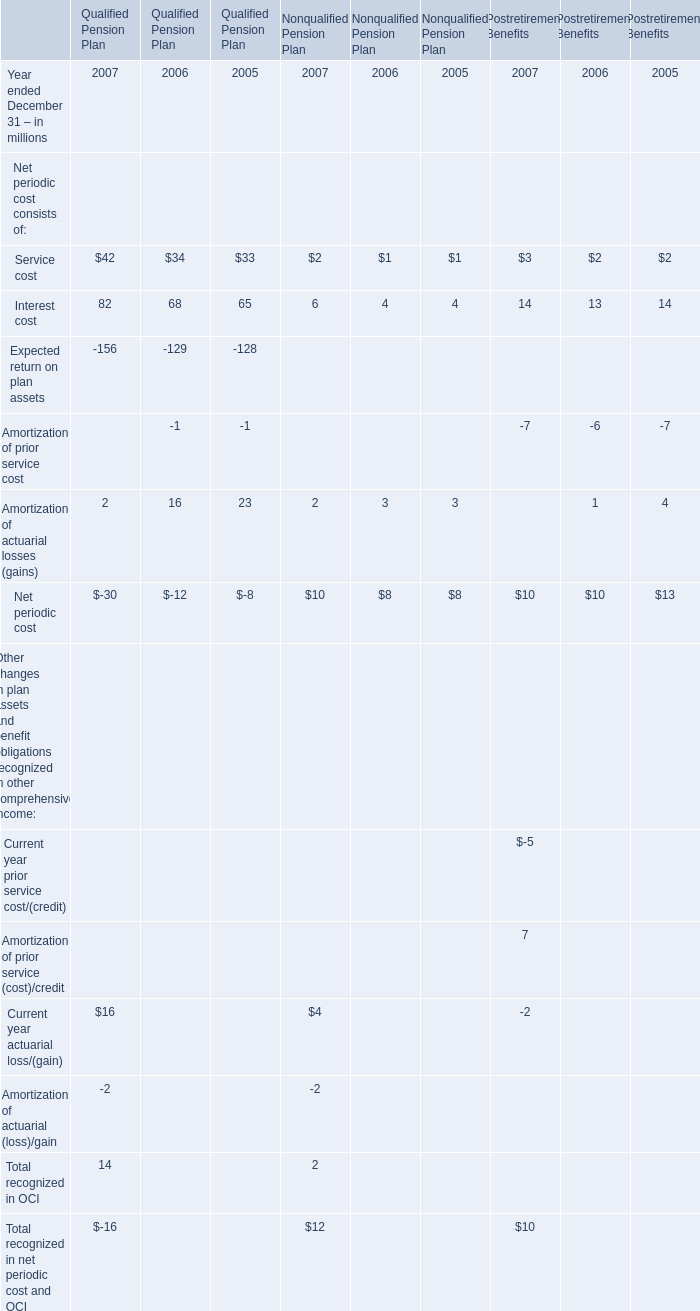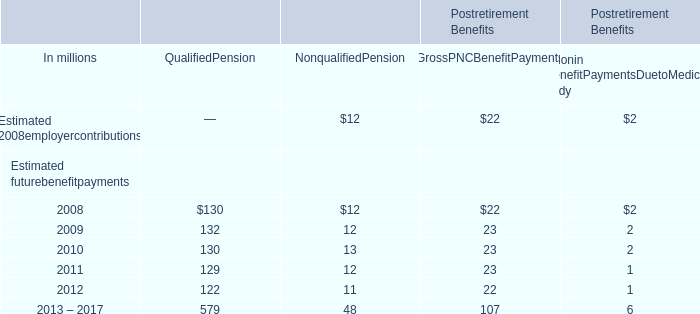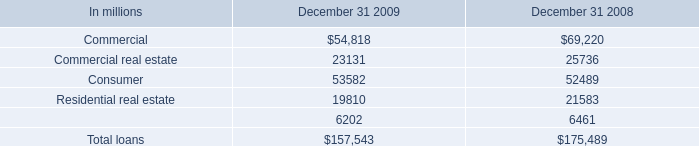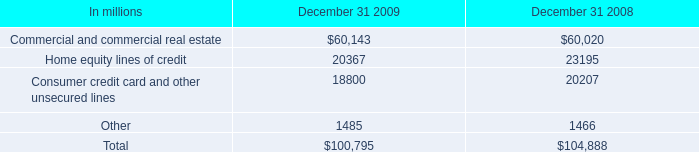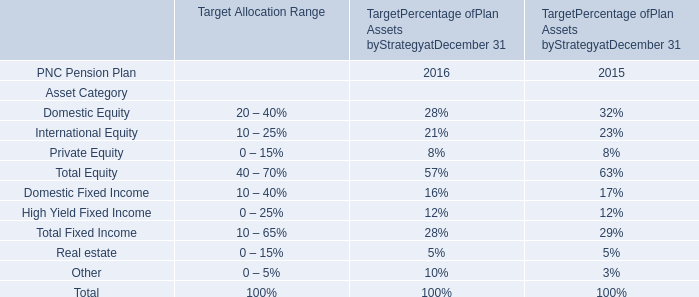What's the total value of all Estimated futurebenefitpayments that are smaller than 20 in 2008? (in million) 
Computations: (12 + 2)
Answer: 14.0. 